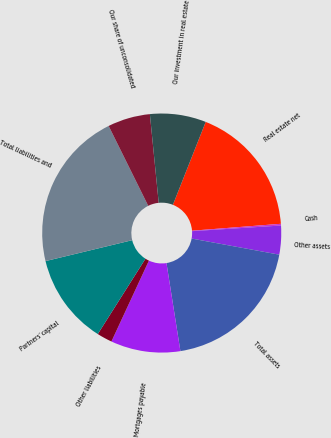Convert chart. <chart><loc_0><loc_0><loc_500><loc_500><pie_chart><fcel>Real estate net<fcel>Cash<fcel>Other assets<fcel>Total assets<fcel>Mortgages payable<fcel>Other liabilities<fcel>Partners' capital<fcel>Total liabilities and<fcel>Our share of unconsolidated<fcel>Our investment in real estate<nl><fcel>17.77%<fcel>0.23%<fcel>3.9%<fcel>19.61%<fcel>9.41%<fcel>2.07%<fcel>12.25%<fcel>21.45%<fcel>5.74%<fcel>7.58%<nl></chart> 